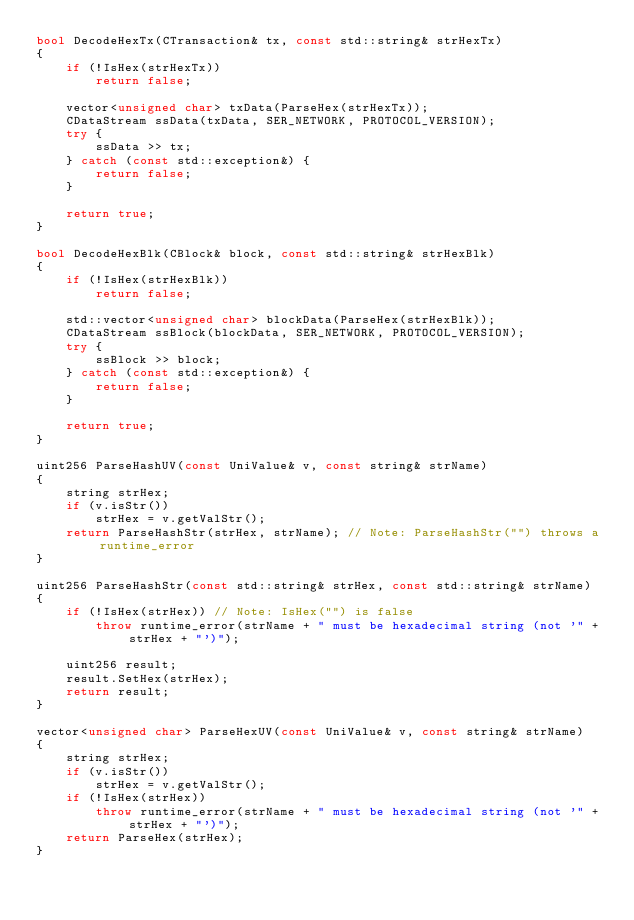Convert code to text. <code><loc_0><loc_0><loc_500><loc_500><_C++_>bool DecodeHexTx(CTransaction& tx, const std::string& strHexTx)
{
    if (!IsHex(strHexTx))
        return false;

    vector<unsigned char> txData(ParseHex(strHexTx));
    CDataStream ssData(txData, SER_NETWORK, PROTOCOL_VERSION);
    try {
        ssData >> tx;
    } catch (const std::exception&) {
        return false;
    }

    return true;
}

bool DecodeHexBlk(CBlock& block, const std::string& strHexBlk)
{
    if (!IsHex(strHexBlk))
        return false;

    std::vector<unsigned char> blockData(ParseHex(strHexBlk));
    CDataStream ssBlock(blockData, SER_NETWORK, PROTOCOL_VERSION);
    try {
        ssBlock >> block;
    } catch (const std::exception&) {
        return false;
    }

    return true;
}

uint256 ParseHashUV(const UniValue& v, const string& strName)
{
    string strHex;
    if (v.isStr())
        strHex = v.getValStr();
    return ParseHashStr(strHex, strName); // Note: ParseHashStr("") throws a runtime_error
}

uint256 ParseHashStr(const std::string& strHex, const std::string& strName)
{
    if (!IsHex(strHex)) // Note: IsHex("") is false
        throw runtime_error(strName + " must be hexadecimal string (not '" + strHex + "')");

    uint256 result;
    result.SetHex(strHex);
    return result;
}

vector<unsigned char> ParseHexUV(const UniValue& v, const string& strName)
{
    string strHex;
    if (v.isStr())
        strHex = v.getValStr();
    if (!IsHex(strHex))
        throw runtime_error(strName + " must be hexadecimal string (not '" + strHex + "')");
    return ParseHex(strHex);
}
</code> 